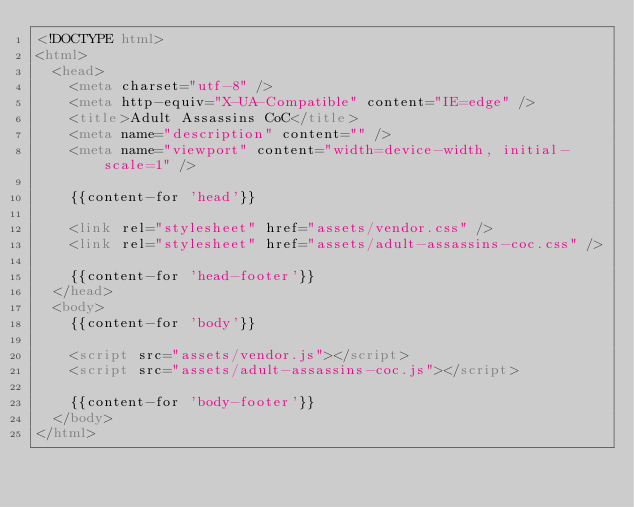Convert code to text. <code><loc_0><loc_0><loc_500><loc_500><_HTML_><!DOCTYPE html>
<html>
  <head>
    <meta charset="utf-8" />
    <meta http-equiv="X-UA-Compatible" content="IE=edge" />
    <title>Adult Assassins CoC</title>
    <meta name="description" content="" />
    <meta name="viewport" content="width=device-width, initial-scale=1" />

    {{content-for 'head'}}

    <link rel="stylesheet" href="assets/vendor.css" />
    <link rel="stylesheet" href="assets/adult-assassins-coc.css" />

    {{content-for 'head-footer'}}
  </head>
  <body>
    {{content-for 'body'}}

    <script src="assets/vendor.js"></script>
    <script src="assets/adult-assassins-coc.js"></script>

    {{content-for 'body-footer'}}
  </body>
</html>
</code> 